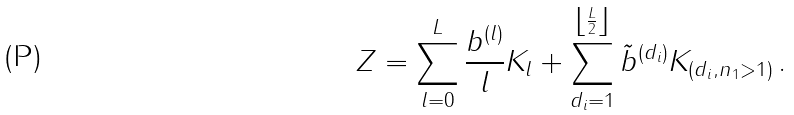<formula> <loc_0><loc_0><loc_500><loc_500>Z = \sum _ { l = 0 } ^ { L } \frac { b ^ { ( l ) } } { l } K _ { l } + \sum _ { d _ { i } = 1 } ^ { \left \lfloor \frac { L } { 2 } \right \rfloor } \tilde { b } ^ { ( d _ { i } ) } K _ { ( d _ { i } , n _ { 1 } > 1 ) } \, .</formula> 